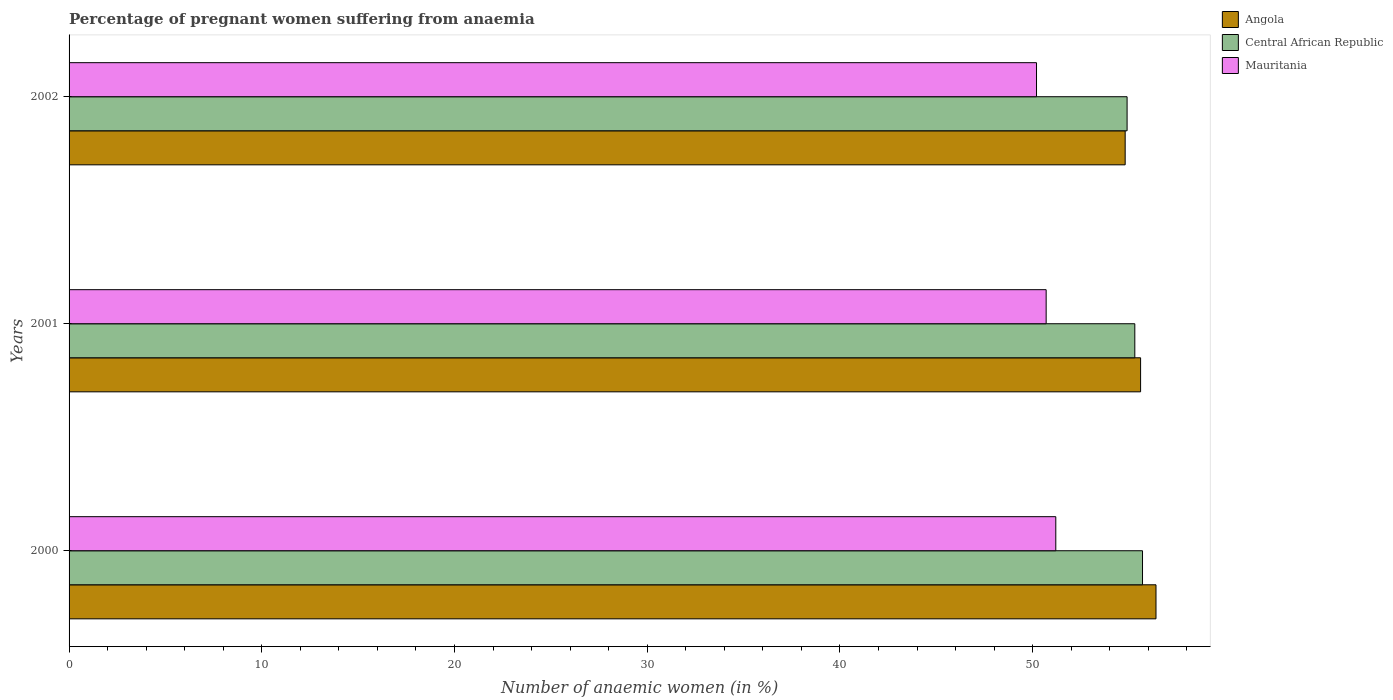How many different coloured bars are there?
Offer a very short reply. 3. Are the number of bars per tick equal to the number of legend labels?
Make the answer very short. Yes. How many bars are there on the 2nd tick from the top?
Your response must be concise. 3. In how many cases, is the number of bars for a given year not equal to the number of legend labels?
Offer a very short reply. 0. What is the number of anaemic women in Angola in 2000?
Keep it short and to the point. 56.4. Across all years, what is the maximum number of anaemic women in Mauritania?
Provide a succinct answer. 51.2. Across all years, what is the minimum number of anaemic women in Central African Republic?
Make the answer very short. 54.9. In which year was the number of anaemic women in Central African Republic maximum?
Give a very brief answer. 2000. What is the total number of anaemic women in Mauritania in the graph?
Provide a short and direct response. 152.1. What is the difference between the number of anaemic women in Mauritania in 2000 and the number of anaemic women in Central African Republic in 2002?
Your answer should be very brief. -3.7. What is the average number of anaemic women in Angola per year?
Provide a short and direct response. 55.6. In the year 2002, what is the difference between the number of anaemic women in Central African Republic and number of anaemic women in Mauritania?
Give a very brief answer. 4.7. What is the ratio of the number of anaemic women in Angola in 2000 to that in 2002?
Your answer should be compact. 1.03. Is the number of anaemic women in Central African Republic in 2000 less than that in 2001?
Ensure brevity in your answer.  No. What is the difference between the highest and the second highest number of anaemic women in Central African Republic?
Ensure brevity in your answer.  0.4. In how many years, is the number of anaemic women in Angola greater than the average number of anaemic women in Angola taken over all years?
Offer a very short reply. 1. What does the 1st bar from the top in 2002 represents?
Offer a very short reply. Mauritania. What does the 2nd bar from the bottom in 2000 represents?
Your response must be concise. Central African Republic. Is it the case that in every year, the sum of the number of anaemic women in Mauritania and number of anaemic women in Angola is greater than the number of anaemic women in Central African Republic?
Ensure brevity in your answer.  Yes. Are all the bars in the graph horizontal?
Give a very brief answer. Yes. Does the graph contain any zero values?
Your response must be concise. No. Does the graph contain grids?
Offer a terse response. No. How many legend labels are there?
Make the answer very short. 3. What is the title of the graph?
Ensure brevity in your answer.  Percentage of pregnant women suffering from anaemia. Does "Kosovo" appear as one of the legend labels in the graph?
Your answer should be very brief. No. What is the label or title of the X-axis?
Your answer should be compact. Number of anaemic women (in %). What is the Number of anaemic women (in %) of Angola in 2000?
Provide a short and direct response. 56.4. What is the Number of anaemic women (in %) of Central African Republic in 2000?
Your response must be concise. 55.7. What is the Number of anaemic women (in %) in Mauritania in 2000?
Provide a succinct answer. 51.2. What is the Number of anaemic women (in %) in Angola in 2001?
Your answer should be compact. 55.6. What is the Number of anaemic women (in %) of Central African Republic in 2001?
Provide a succinct answer. 55.3. What is the Number of anaemic women (in %) of Mauritania in 2001?
Give a very brief answer. 50.7. What is the Number of anaemic women (in %) of Angola in 2002?
Keep it short and to the point. 54.8. What is the Number of anaemic women (in %) of Central African Republic in 2002?
Give a very brief answer. 54.9. What is the Number of anaemic women (in %) of Mauritania in 2002?
Your answer should be compact. 50.2. Across all years, what is the maximum Number of anaemic women (in %) of Angola?
Offer a terse response. 56.4. Across all years, what is the maximum Number of anaemic women (in %) in Central African Republic?
Your answer should be compact. 55.7. Across all years, what is the maximum Number of anaemic women (in %) in Mauritania?
Offer a terse response. 51.2. Across all years, what is the minimum Number of anaemic women (in %) in Angola?
Ensure brevity in your answer.  54.8. Across all years, what is the minimum Number of anaemic women (in %) in Central African Republic?
Give a very brief answer. 54.9. Across all years, what is the minimum Number of anaemic women (in %) of Mauritania?
Provide a short and direct response. 50.2. What is the total Number of anaemic women (in %) of Angola in the graph?
Offer a very short reply. 166.8. What is the total Number of anaemic women (in %) in Central African Republic in the graph?
Offer a very short reply. 165.9. What is the total Number of anaemic women (in %) in Mauritania in the graph?
Your answer should be compact. 152.1. What is the difference between the Number of anaemic women (in %) in Central African Republic in 2000 and that in 2001?
Provide a succinct answer. 0.4. What is the difference between the Number of anaemic women (in %) of Angola in 2000 and the Number of anaemic women (in %) of Central African Republic in 2001?
Your answer should be very brief. 1.1. What is the difference between the Number of anaemic women (in %) in Angola in 2000 and the Number of anaemic women (in %) in Mauritania in 2001?
Offer a very short reply. 5.7. What is the difference between the Number of anaemic women (in %) of Angola in 2000 and the Number of anaemic women (in %) of Central African Republic in 2002?
Offer a terse response. 1.5. What is the difference between the Number of anaemic women (in %) in Angola in 2001 and the Number of anaemic women (in %) in Mauritania in 2002?
Give a very brief answer. 5.4. What is the difference between the Number of anaemic women (in %) in Central African Republic in 2001 and the Number of anaemic women (in %) in Mauritania in 2002?
Offer a terse response. 5.1. What is the average Number of anaemic women (in %) in Angola per year?
Ensure brevity in your answer.  55.6. What is the average Number of anaemic women (in %) in Central African Republic per year?
Keep it short and to the point. 55.3. What is the average Number of anaemic women (in %) of Mauritania per year?
Provide a succinct answer. 50.7. In the year 2000, what is the difference between the Number of anaemic women (in %) of Angola and Number of anaemic women (in %) of Central African Republic?
Offer a very short reply. 0.7. In the year 2002, what is the difference between the Number of anaemic women (in %) in Angola and Number of anaemic women (in %) in Central African Republic?
Offer a very short reply. -0.1. What is the ratio of the Number of anaemic women (in %) in Angola in 2000 to that in 2001?
Your response must be concise. 1.01. What is the ratio of the Number of anaemic women (in %) in Central African Republic in 2000 to that in 2001?
Give a very brief answer. 1.01. What is the ratio of the Number of anaemic women (in %) in Mauritania in 2000 to that in 2001?
Provide a succinct answer. 1.01. What is the ratio of the Number of anaemic women (in %) of Angola in 2000 to that in 2002?
Provide a succinct answer. 1.03. What is the ratio of the Number of anaemic women (in %) of Central African Republic in 2000 to that in 2002?
Provide a succinct answer. 1.01. What is the ratio of the Number of anaemic women (in %) in Mauritania in 2000 to that in 2002?
Keep it short and to the point. 1.02. What is the ratio of the Number of anaemic women (in %) in Angola in 2001 to that in 2002?
Offer a terse response. 1.01. What is the ratio of the Number of anaemic women (in %) in Central African Republic in 2001 to that in 2002?
Provide a succinct answer. 1.01. What is the difference between the highest and the second highest Number of anaemic women (in %) in Angola?
Offer a very short reply. 0.8. What is the difference between the highest and the lowest Number of anaemic women (in %) in Central African Republic?
Make the answer very short. 0.8. What is the difference between the highest and the lowest Number of anaemic women (in %) in Mauritania?
Your response must be concise. 1. 